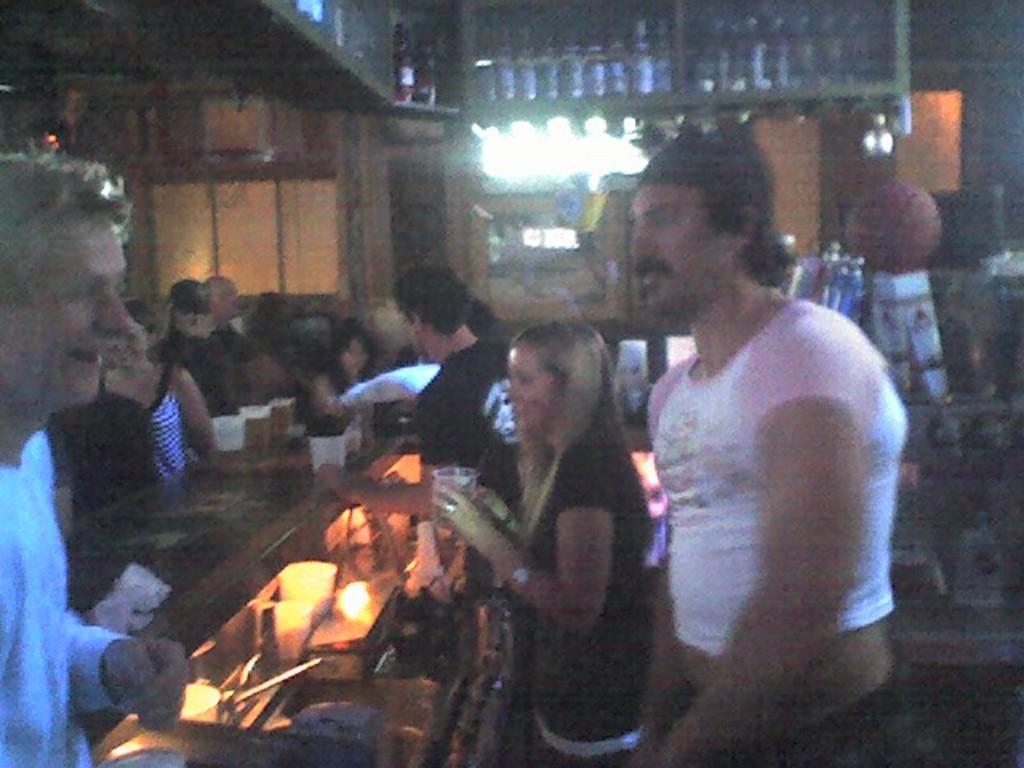Please provide a concise description of this image. In this image, we can see a lady holding glass in her hands and there are many people, we can see some glasses placed on the table. At the top, there are bottles in the shelf. 